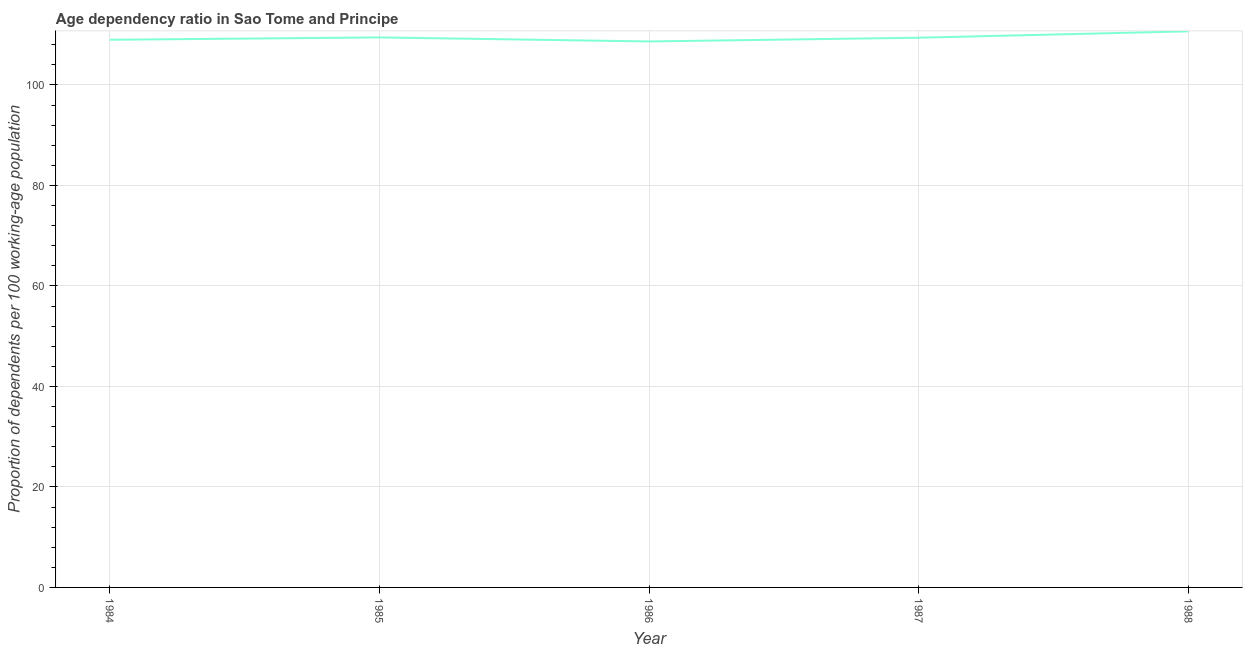What is the age dependency ratio in 1987?
Offer a terse response. 109.4. Across all years, what is the maximum age dependency ratio?
Provide a succinct answer. 110.67. Across all years, what is the minimum age dependency ratio?
Give a very brief answer. 108.65. In which year was the age dependency ratio maximum?
Provide a short and direct response. 1988. In which year was the age dependency ratio minimum?
Provide a short and direct response. 1986. What is the sum of the age dependency ratio?
Your answer should be compact. 547.18. What is the difference between the age dependency ratio in 1985 and 1988?
Keep it short and to the point. -1.21. What is the average age dependency ratio per year?
Provide a succinct answer. 109.44. What is the median age dependency ratio?
Make the answer very short. 109.4. In how many years, is the age dependency ratio greater than 84 ?
Offer a very short reply. 5. Do a majority of the years between 1985 and 1984 (inclusive) have age dependency ratio greater than 48 ?
Offer a very short reply. No. What is the ratio of the age dependency ratio in 1987 to that in 1988?
Offer a terse response. 0.99. What is the difference between the highest and the second highest age dependency ratio?
Give a very brief answer. 1.21. What is the difference between the highest and the lowest age dependency ratio?
Keep it short and to the point. 2.02. What is the difference between two consecutive major ticks on the Y-axis?
Offer a terse response. 20. What is the title of the graph?
Your answer should be very brief. Age dependency ratio in Sao Tome and Principe. What is the label or title of the X-axis?
Provide a succinct answer. Year. What is the label or title of the Y-axis?
Offer a terse response. Proportion of dependents per 100 working-age population. What is the Proportion of dependents per 100 working-age population in 1984?
Give a very brief answer. 108.99. What is the Proportion of dependents per 100 working-age population of 1985?
Make the answer very short. 109.46. What is the Proportion of dependents per 100 working-age population of 1986?
Provide a short and direct response. 108.65. What is the Proportion of dependents per 100 working-age population of 1987?
Offer a terse response. 109.4. What is the Proportion of dependents per 100 working-age population of 1988?
Offer a very short reply. 110.67. What is the difference between the Proportion of dependents per 100 working-age population in 1984 and 1985?
Provide a succinct answer. -0.47. What is the difference between the Proportion of dependents per 100 working-age population in 1984 and 1986?
Offer a terse response. 0.34. What is the difference between the Proportion of dependents per 100 working-age population in 1984 and 1987?
Give a very brief answer. -0.41. What is the difference between the Proportion of dependents per 100 working-age population in 1984 and 1988?
Your answer should be compact. -1.68. What is the difference between the Proportion of dependents per 100 working-age population in 1985 and 1986?
Your answer should be very brief. 0.81. What is the difference between the Proportion of dependents per 100 working-age population in 1985 and 1987?
Provide a short and direct response. 0.06. What is the difference between the Proportion of dependents per 100 working-age population in 1985 and 1988?
Your response must be concise. -1.21. What is the difference between the Proportion of dependents per 100 working-age population in 1986 and 1987?
Offer a very short reply. -0.75. What is the difference between the Proportion of dependents per 100 working-age population in 1986 and 1988?
Give a very brief answer. -2.02. What is the difference between the Proportion of dependents per 100 working-age population in 1987 and 1988?
Your response must be concise. -1.27. What is the ratio of the Proportion of dependents per 100 working-age population in 1984 to that in 1985?
Your answer should be very brief. 1. What is the ratio of the Proportion of dependents per 100 working-age population in 1984 to that in 1986?
Give a very brief answer. 1. What is the ratio of the Proportion of dependents per 100 working-age population in 1985 to that in 1986?
Make the answer very short. 1.01. What is the ratio of the Proportion of dependents per 100 working-age population in 1985 to that in 1987?
Keep it short and to the point. 1. What is the ratio of the Proportion of dependents per 100 working-age population in 1985 to that in 1988?
Your answer should be compact. 0.99. What is the ratio of the Proportion of dependents per 100 working-age population in 1986 to that in 1987?
Keep it short and to the point. 0.99. 